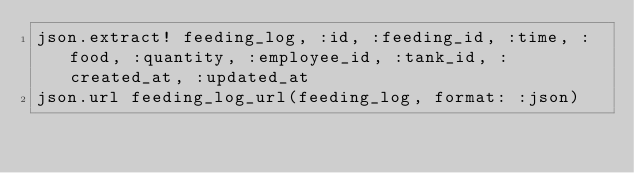Convert code to text. <code><loc_0><loc_0><loc_500><loc_500><_Ruby_>json.extract! feeding_log, :id, :feeding_id, :time, :food, :quantity, :employee_id, :tank_id, :created_at, :updated_at
json.url feeding_log_url(feeding_log, format: :json)
</code> 